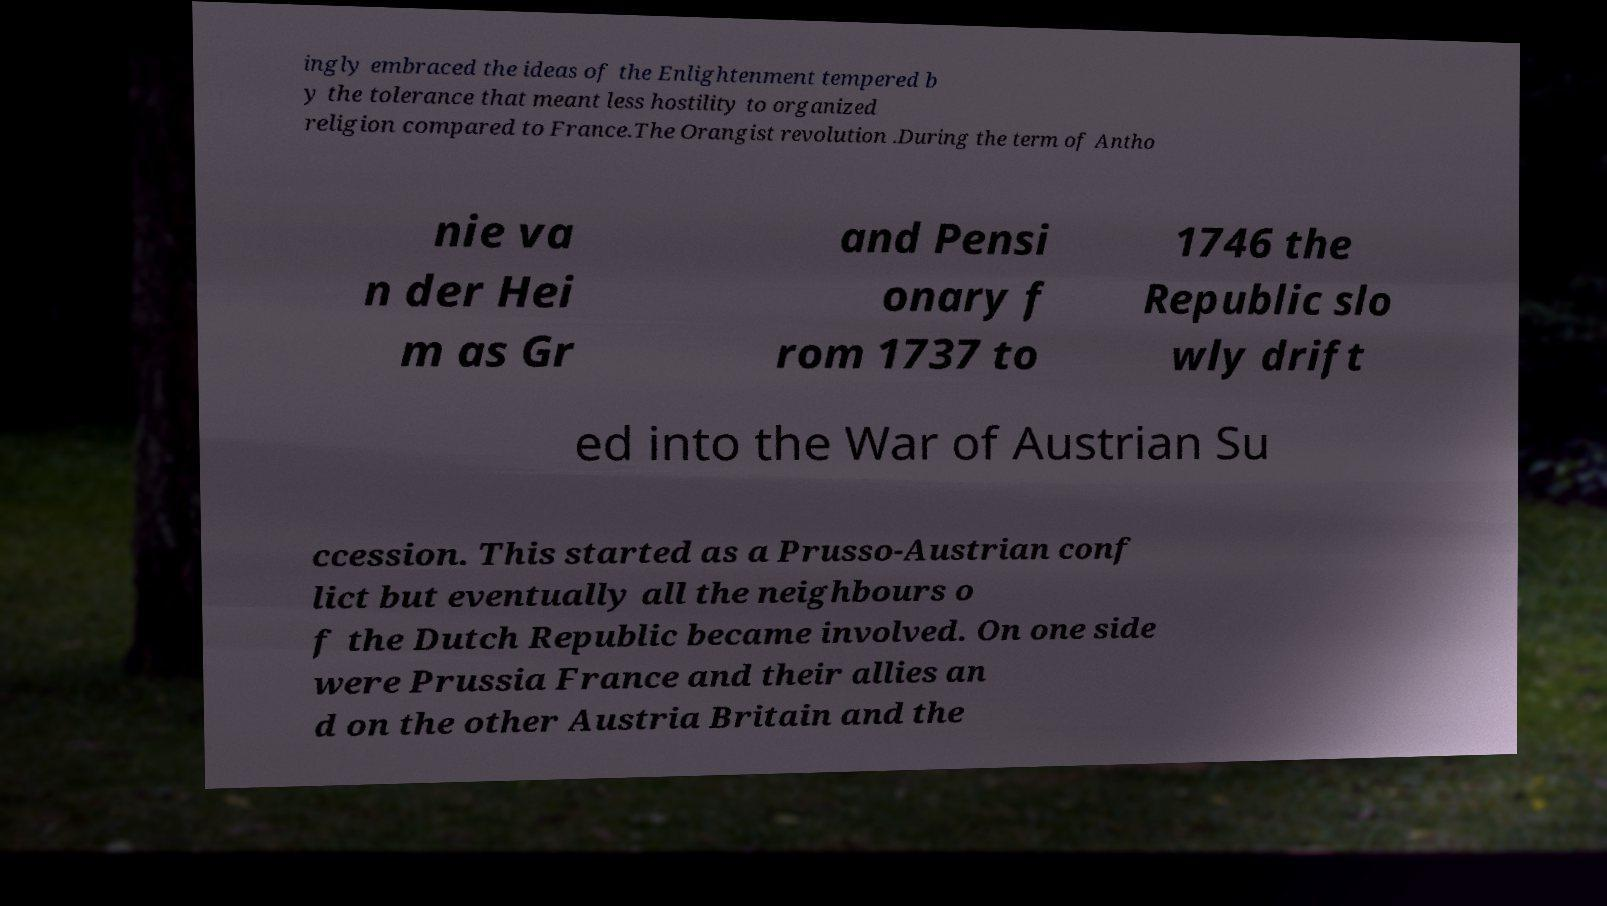For documentation purposes, I need the text within this image transcribed. Could you provide that? ingly embraced the ideas of the Enlightenment tempered b y the tolerance that meant less hostility to organized religion compared to France.The Orangist revolution .During the term of Antho nie va n der Hei m as Gr and Pensi onary f rom 1737 to 1746 the Republic slo wly drift ed into the War of Austrian Su ccession. This started as a Prusso-Austrian conf lict but eventually all the neighbours o f the Dutch Republic became involved. On one side were Prussia France and their allies an d on the other Austria Britain and the 